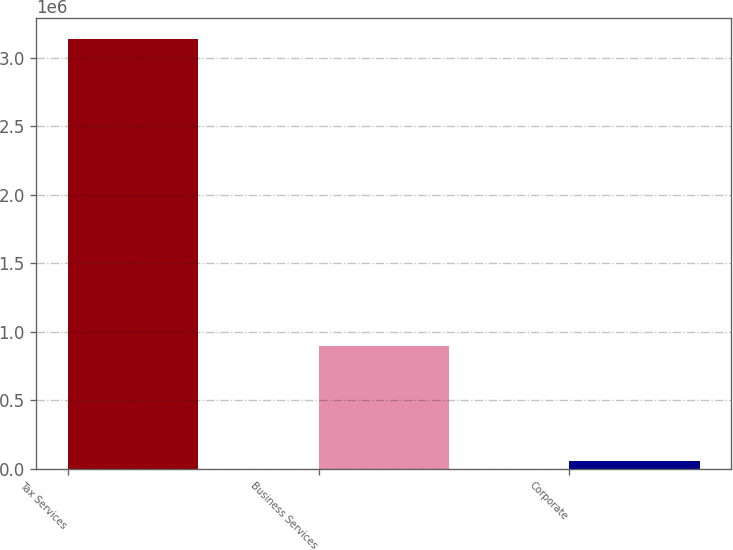<chart> <loc_0><loc_0><loc_500><loc_500><bar_chart><fcel>Tax Services<fcel>Business Services<fcel>Corporate<nl><fcel>3.13208e+06<fcel>897809<fcel>53691<nl></chart> 